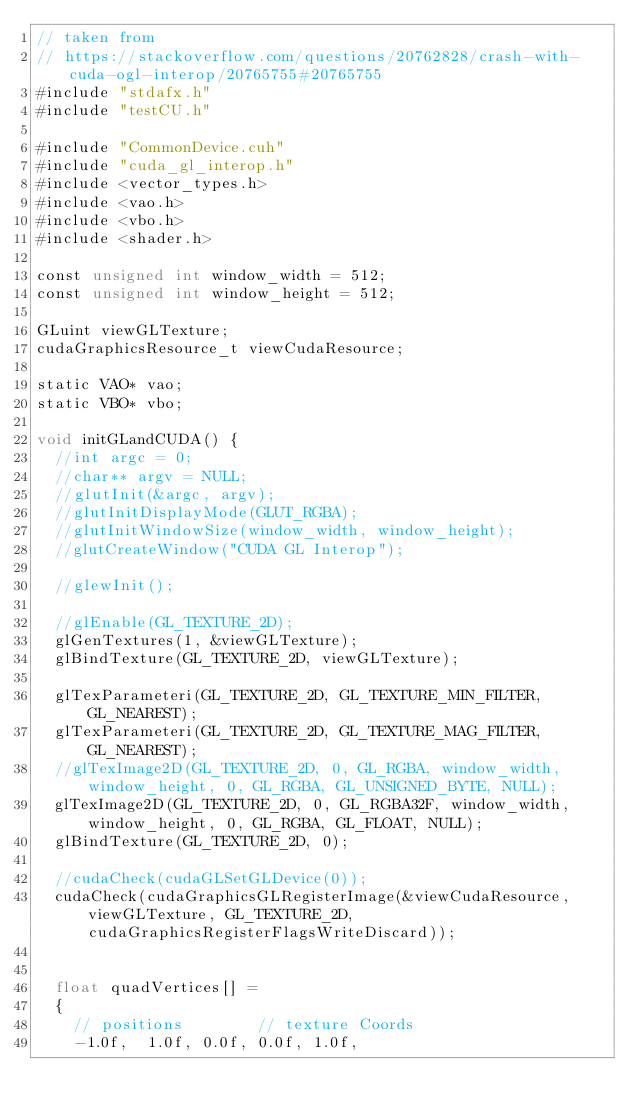<code> <loc_0><loc_0><loc_500><loc_500><_Cuda_>// taken from
// https://stackoverflow.com/questions/20762828/crash-with-cuda-ogl-interop/20765755#20765755
#include "stdafx.h"
#include "testCU.h"

#include "CommonDevice.cuh"
#include "cuda_gl_interop.h"
#include <vector_types.h>
#include <vao.h>
#include <vbo.h>
#include <shader.h>

const unsigned int window_width = 512;
const unsigned int window_height = 512;

GLuint viewGLTexture;
cudaGraphicsResource_t viewCudaResource;

static VAO* vao;
static VBO* vbo;

void initGLandCUDA() {
  //int argc = 0;
  //char** argv = NULL;
  //glutInit(&argc, argv);
  //glutInitDisplayMode(GLUT_RGBA);
  //glutInitWindowSize(window_width, window_height);
  //glutCreateWindow("CUDA GL Interop");

  //glewInit();

  //glEnable(GL_TEXTURE_2D);
  glGenTextures(1, &viewGLTexture);
  glBindTexture(GL_TEXTURE_2D, viewGLTexture);

  glTexParameteri(GL_TEXTURE_2D, GL_TEXTURE_MIN_FILTER, GL_NEAREST);
  glTexParameteri(GL_TEXTURE_2D, GL_TEXTURE_MAG_FILTER, GL_NEAREST);
  //glTexImage2D(GL_TEXTURE_2D, 0, GL_RGBA, window_width, window_height, 0, GL_RGBA, GL_UNSIGNED_BYTE, NULL);
  glTexImage2D(GL_TEXTURE_2D, 0, GL_RGBA32F, window_width, window_height, 0, GL_RGBA, GL_FLOAT, NULL);
  glBindTexture(GL_TEXTURE_2D, 0);

  //cudaCheck(cudaGLSetGLDevice(0));
  cudaCheck(cudaGraphicsGLRegisterImage(&viewCudaResource, viewGLTexture, GL_TEXTURE_2D, cudaGraphicsRegisterFlagsWriteDiscard));


  float quadVertices[] =
  {
    // positions        // texture Coords
    -1.0f,  1.0f, 0.0f, 0.0f, 1.0f,</code> 